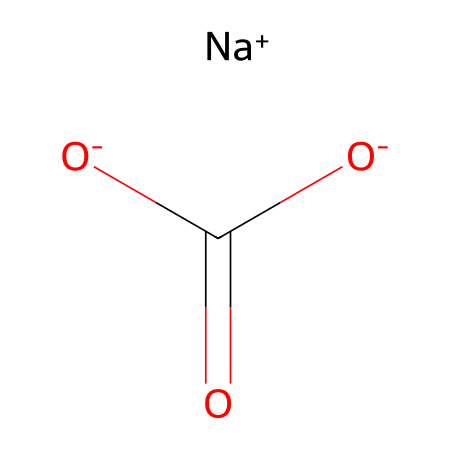What is the name of this compound? The compound represented is sodium bicarbonate, recognized for its ability to function as a leavening agent. This is derived from the chemical name “sodium” (from the sodium ion) and “bicarbonate” (the bicarbonate group).
Answer: sodium bicarbonate How many oxygen atoms are present in the structure? The structural formula shows one carbonate group (C(=O)[O-]) and a bicarbonate ion, which contains a total of three oxygen atoms (two in the bicarbonate and one double-bonded to carbon).
Answer: three What charge is associated with the sodium ion? The sodium ion in the structure is represented as [Na+], indicating that it has a positive charge. This is typical for sodium ions as they lose one electron to achieve stability.
Answer: positive What type of compound is sodium bicarbonate classified as? Sodium bicarbonate is classified as a medicinal compound because it is often used for its therapeutic properties, such as treating acidity. Its role as a leavening agent in cooking further supports its classification in this category.
Answer: medicinal compound Which part of the structure contributes to its leavening ability? The bicarbonate ion (HCO3-) in sodium bicarbonate produces carbon dioxide gas when it reacts with acids during cooking, which is integral to the leavening process in dishes like pajeon. This reaction occurs due to the breakdown of the bicarbonate in the presence of heat and acid.
Answer: bicarbonate ion What is the total number of hydrogen atoms in sodium bicarbonate? In the chemical structure, the bicarbonate group contains one hydrogen atom, hence there is one hydrogen atom present in sodium bicarbonate. The [O-] denotes the remaining oxygen atoms within that structure.
Answer: one 